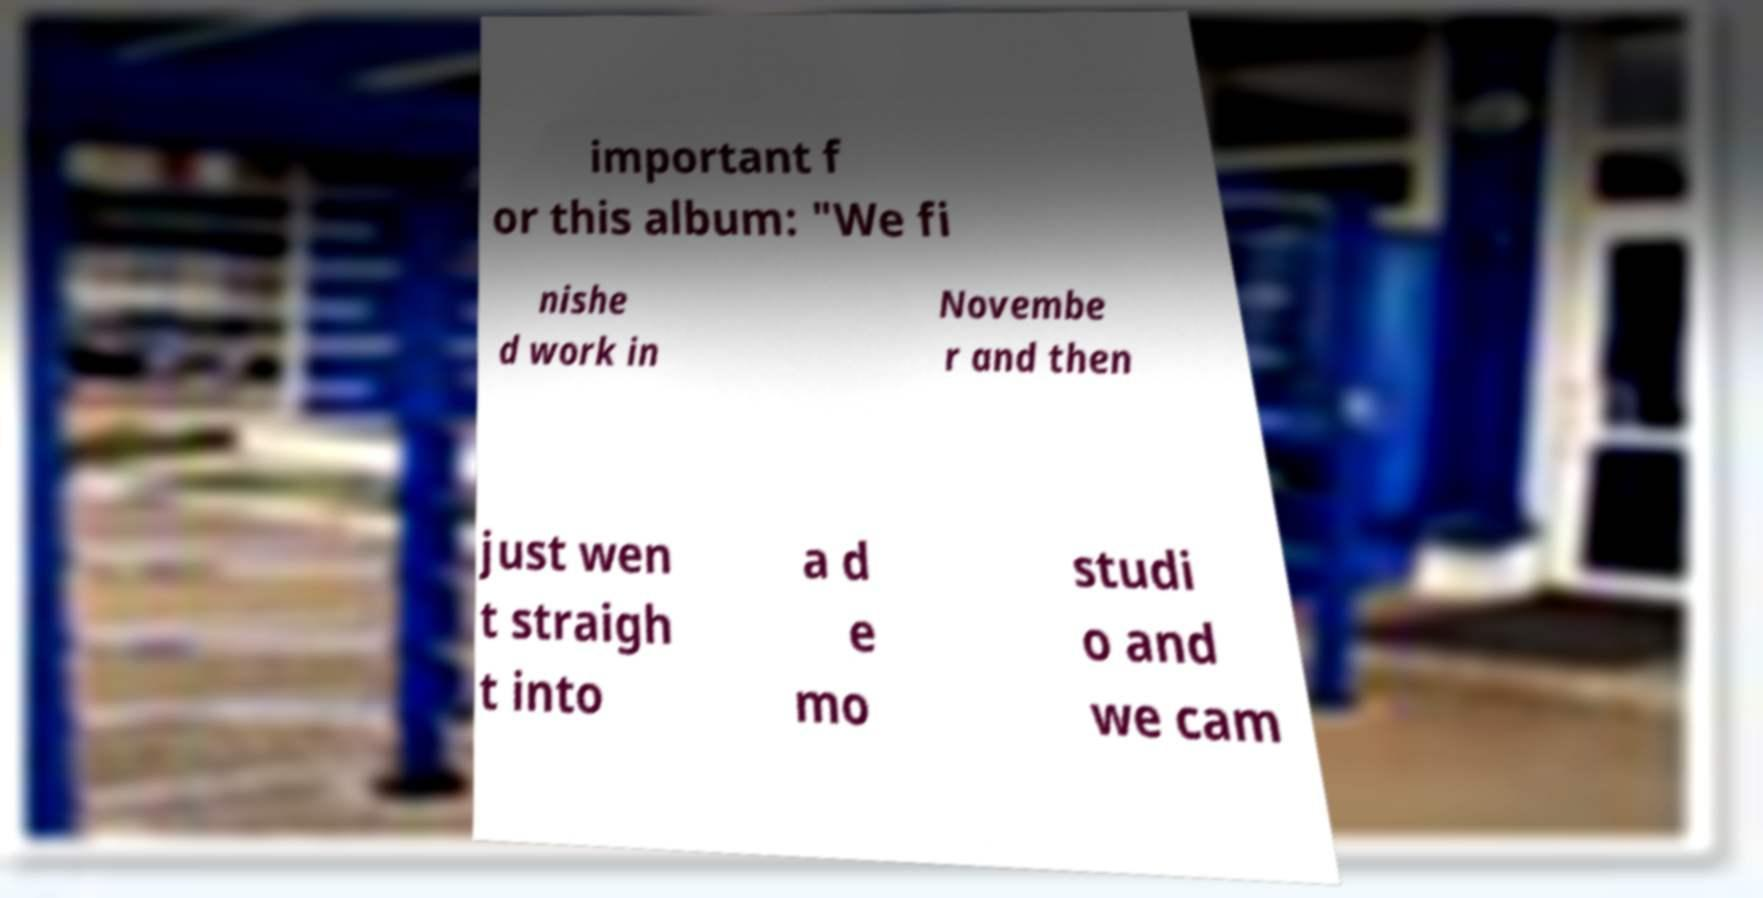For documentation purposes, I need the text within this image transcribed. Could you provide that? important f or this album: "We fi nishe d work in Novembe r and then just wen t straigh t into a d e mo studi o and we cam 